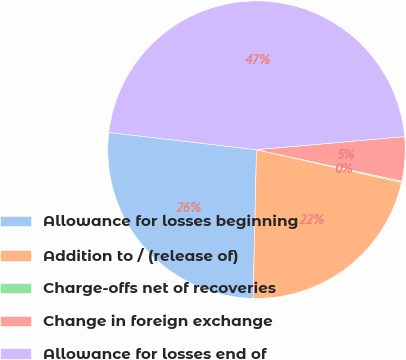Convert chart to OTSL. <chart><loc_0><loc_0><loc_500><loc_500><pie_chart><fcel>Allowance for losses beginning<fcel>Addition to / (release of)<fcel>Charge-offs net of recoveries<fcel>Change in foreign exchange<fcel>Allowance for losses end of<nl><fcel>26.49%<fcel>21.82%<fcel>0.14%<fcel>4.8%<fcel>46.75%<nl></chart> 